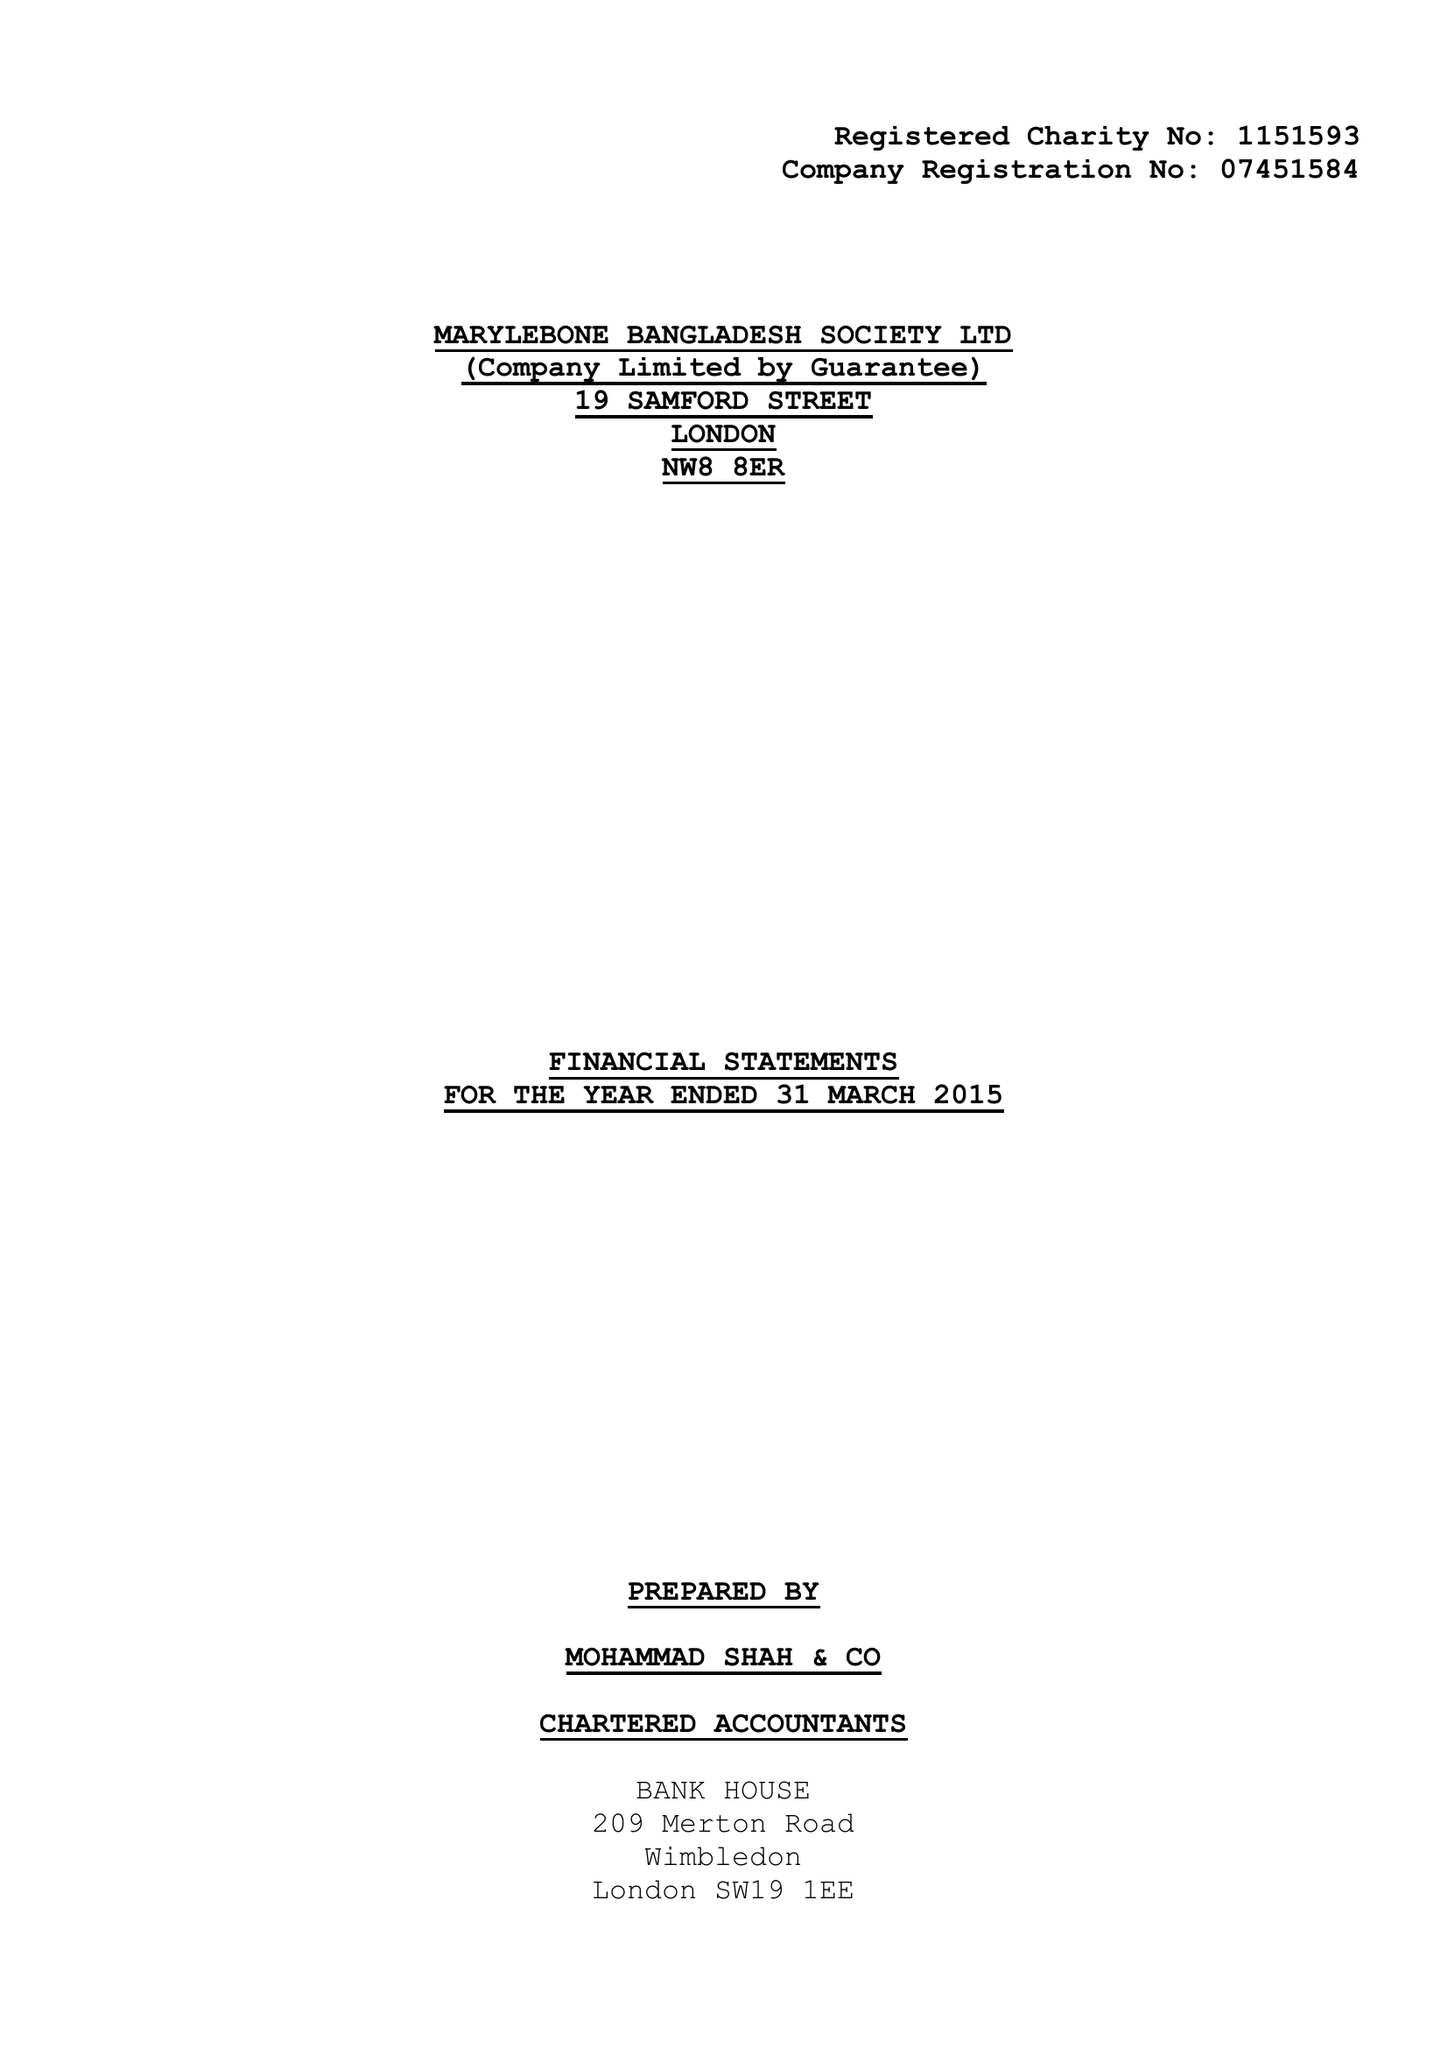What is the value for the address__postcode?
Answer the question using a single word or phrase. NW8 8ER 